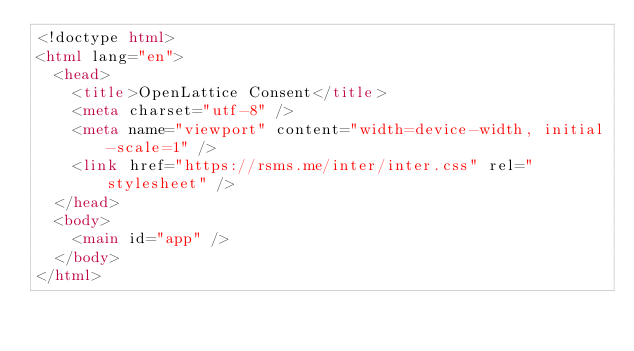<code> <loc_0><loc_0><loc_500><loc_500><_HTML_><!doctype html>
<html lang="en">
  <head>
    <title>OpenLattice Consent</title>
    <meta charset="utf-8" />
    <meta name="viewport" content="width=device-width, initial-scale=1" />
    <link href="https://rsms.me/inter/inter.css" rel="stylesheet" />
  </head>
  <body>
    <main id="app" />
  </body>
</html>
</code> 